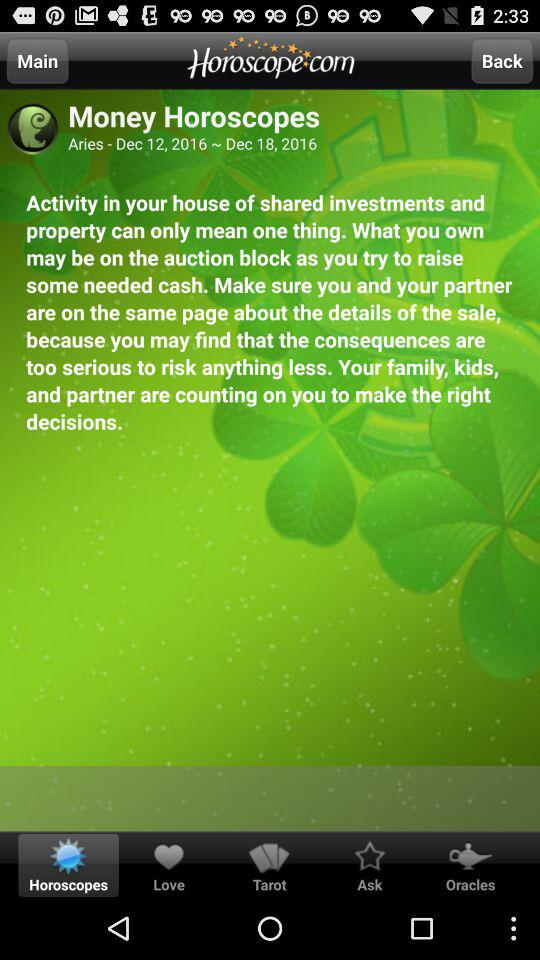For what zodiac sign is the horoscope shown? The horoscope is shown for the Aries zodiac sign. 